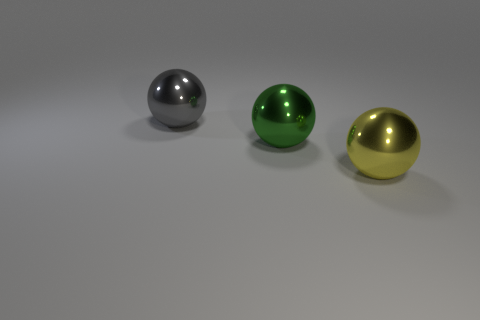Is the yellow ball the same size as the green ball?
Your response must be concise. Yes. How many yellow things are the same size as the green object?
Your answer should be very brief. 1. Are the large ball behind the green metal object and the large ball that is to the right of the green object made of the same material?
Provide a short and direct response. Yes. Is there anything else that has the same shape as the big yellow metal thing?
Keep it short and to the point. Yes. How many tiny purple matte objects have the same shape as the green metallic object?
Ensure brevity in your answer.  0. Is there a large blue matte sphere?
Make the answer very short. No. What shape is the large thing to the left of the green metallic thing?
Your answer should be very brief. Sphere. How many shiny things are behind the large green shiny ball and in front of the gray sphere?
Make the answer very short. 0. Are there any other objects that have the same material as the gray object?
Provide a short and direct response. Yes. How many cubes are either green metal things or large yellow metal things?
Ensure brevity in your answer.  0. 